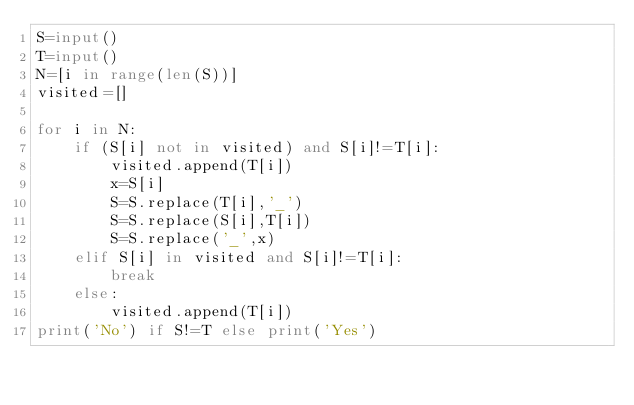Convert code to text. <code><loc_0><loc_0><loc_500><loc_500><_Python_>S=input()
T=input()
N=[i in range(len(S))]
visited=[]

for i in N:
    if (S[i] not in visited) and S[i]!=T[i]:
        visited.append(T[i])
        x=S[i]
        S=S.replace(T[i],'_')
        S=S.replace(S[i],T[i])
        S=S.replace('_',x)
    elif S[i] in visited and S[i]!=T[i]:
        break
    else:
        visited.append(T[i])
print('No') if S!=T else print('Yes')</code> 